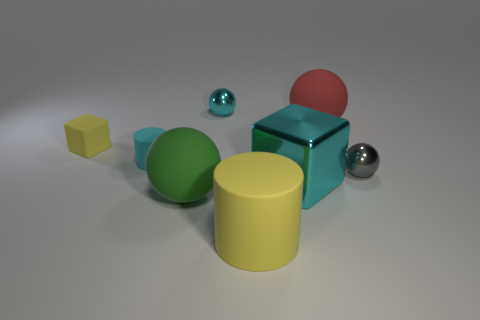Add 2 gray objects. How many objects exist? 10 Subtract all purple balls. Subtract all gray cylinders. How many balls are left? 4 Subtract all cubes. How many objects are left? 6 Subtract 0 brown balls. How many objects are left? 8 Subtract all tiny blue blocks. Subtract all small matte things. How many objects are left? 6 Add 5 tiny gray spheres. How many tiny gray spheres are left? 6 Add 4 green rubber things. How many green rubber things exist? 5 